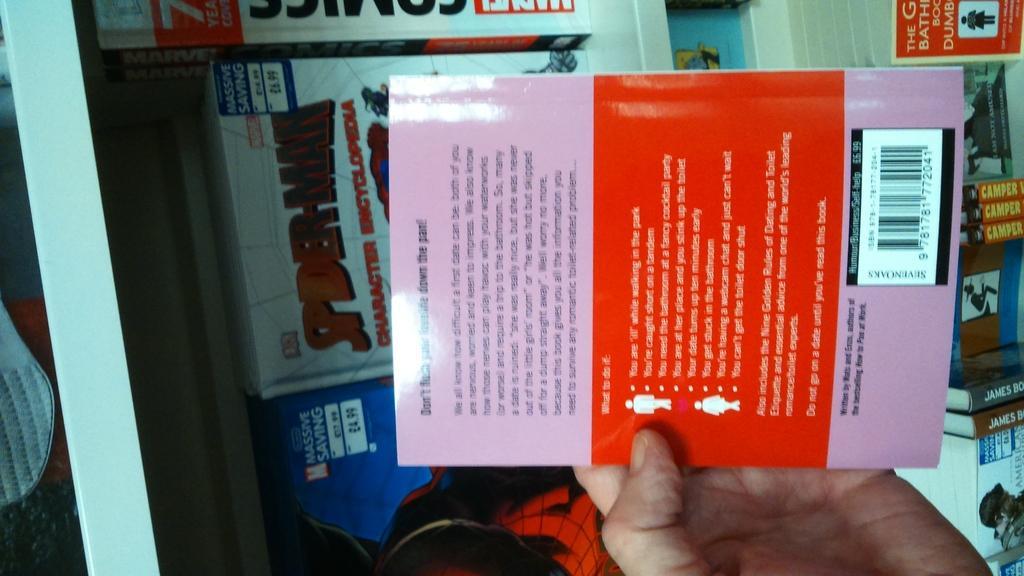Could you give a brief overview of what you see in this image? In the picture there is a person holding a book with the hand, there are books, there is some text. 